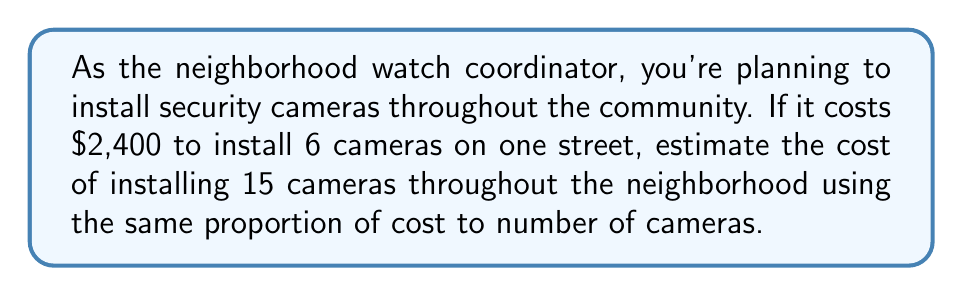Can you solve this math problem? Let's approach this step-by-step using proportions:

1) First, let's set up our proportion:
   $$\frac{\text{Cost for 6 cameras}}{\text{Number of cameras (6)}} = \frac{\text{Cost for 15 cameras}}{\text{Number of cameras (15)}}$$

2) We know the cost for 6 cameras is $2,400, so let's fill that in:
   $$\frac{2400}{6} = \frac{x}{15}$$
   where $x$ is the cost we're trying to find for 15 cameras.

3) Now, let's cross-multiply:
   $$2400 \cdot 15 = 6x$$

4) Simplify the left side:
   $$36000 = 6x$$

5) Divide both sides by 6:
   $$\frac{36000}{6} = x$$

6) Simplify:
   $$6000 = x$$

Therefore, the estimated cost for installing 15 cameras is $6,000.
Answer: $6,000 